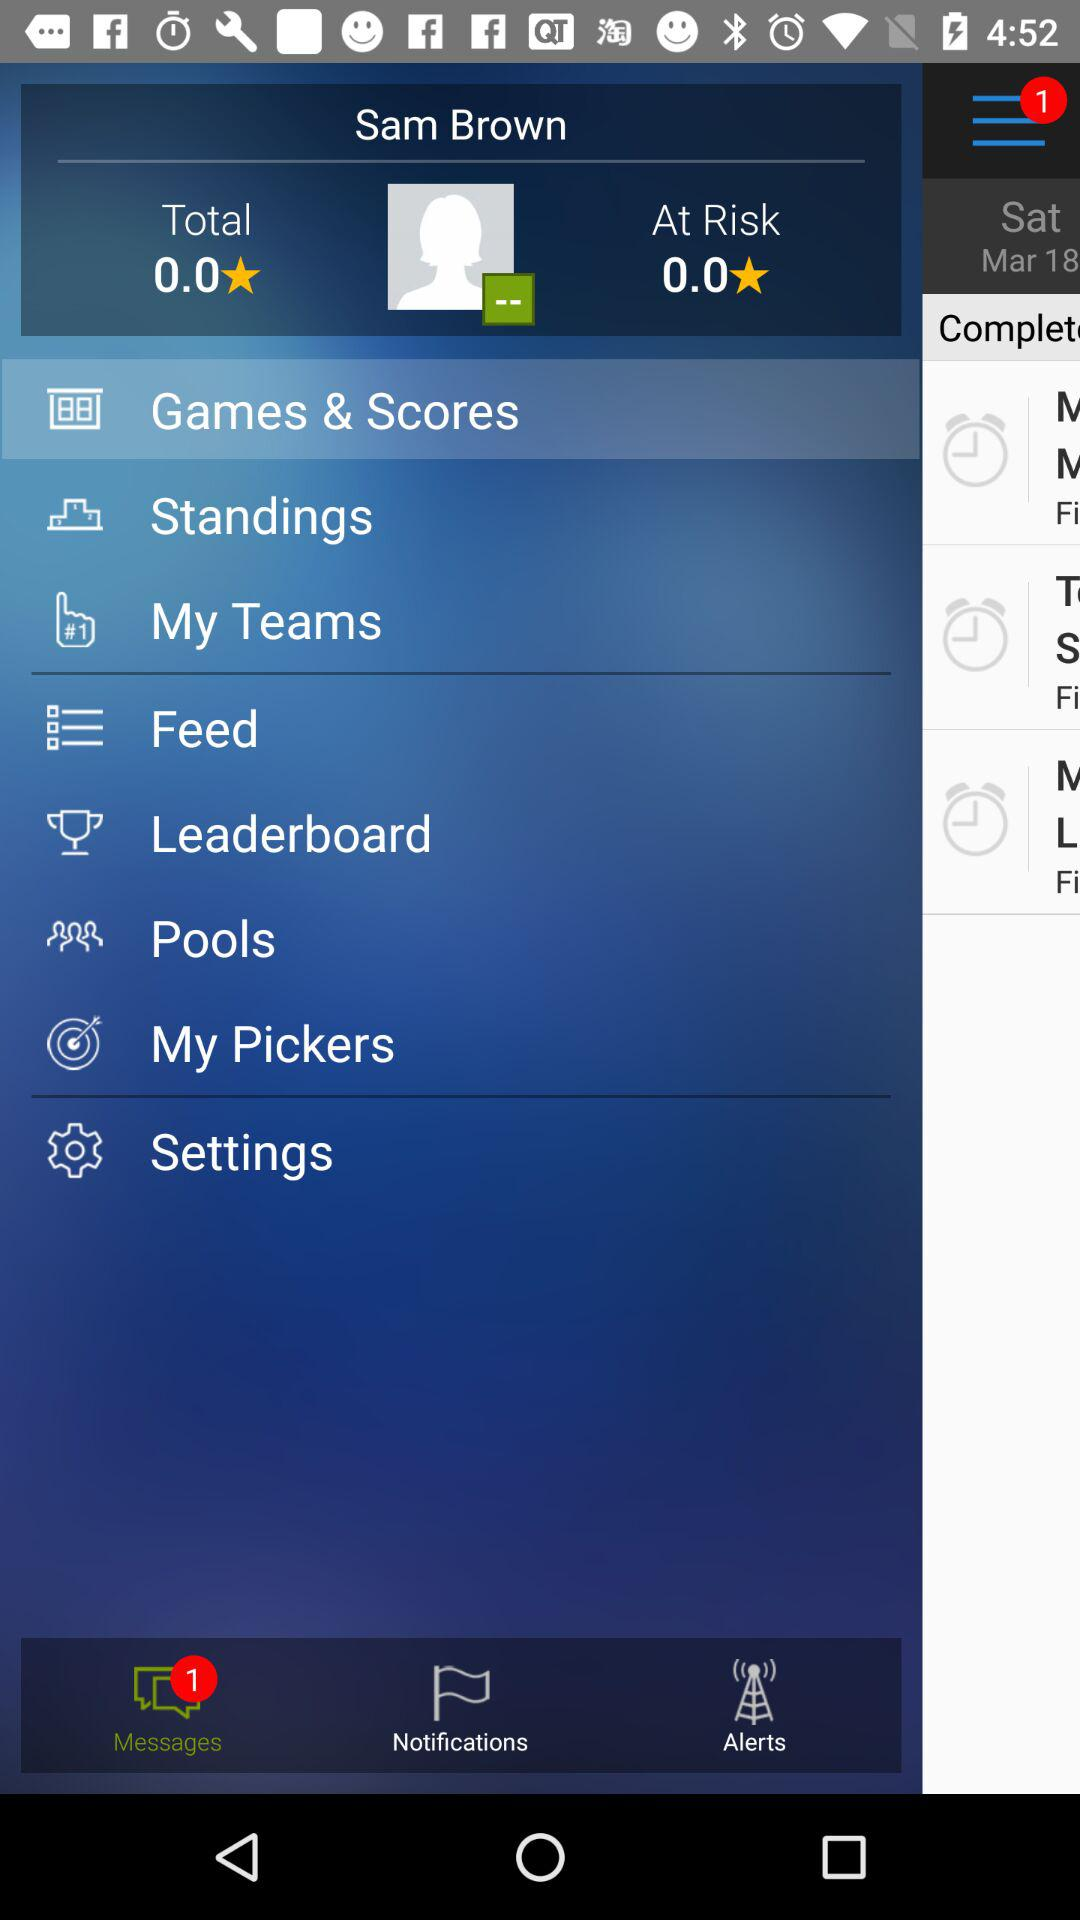What is the selected option? The selected option is "Games & Scores". 